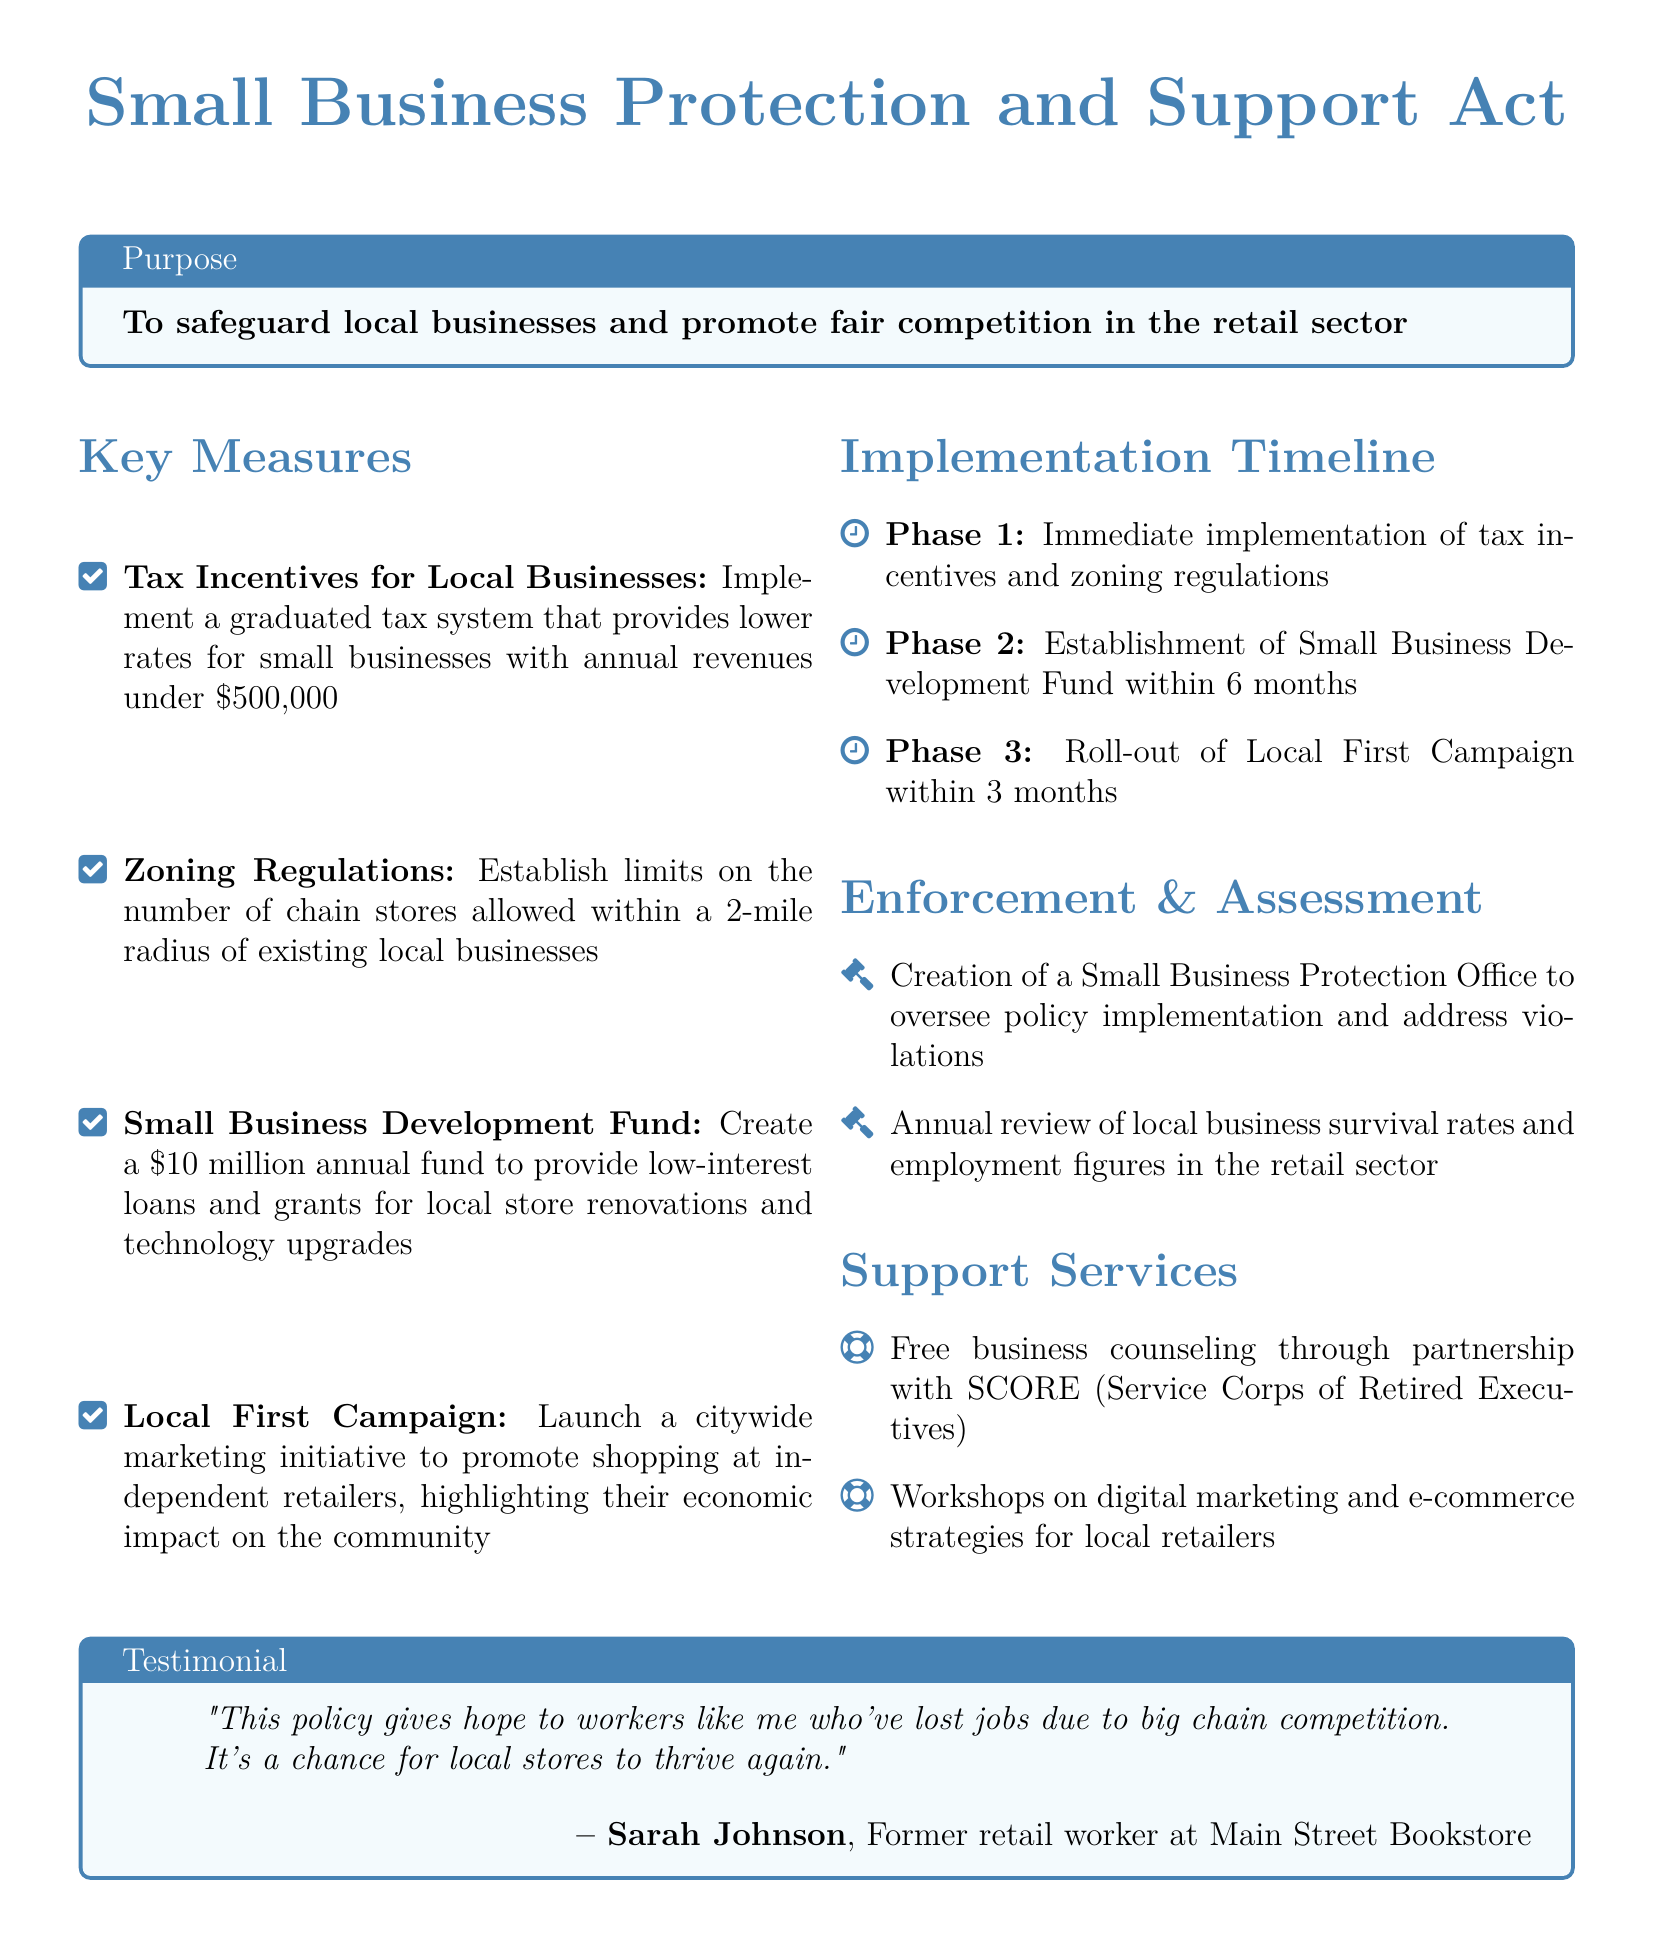What is the purpose of the policy? The purpose is stated to safeguard local businesses and promote fair competition in the retail sector.
Answer: To safeguard local businesses and promote fair competition in the retail sector What is the annual budget for the Small Business Development Fund? The document specifies a budget for the fund to provide support to local stores.
Answer: 10 million What benefits do local businesses receive through tax incentives? The details indicate that the tax system favors small businesses with specific revenue criteria.
Answer: Lower rates How long will it take to establish the Small Business Development Fund? The document outlines a timeline for the fund's establishment.
Answer: Within 6 months What initiative promotes shopping at independent retailers? There is a specific campaign mentioned aimed at encouraging community support for local stores.
Answer: Local First Campaign Who will oversee policy implementation? The document mentions a specific office created for this purpose.
Answer: Small Business Protection Office What kind of support services are offered to local retailers? The document lists various types of support services available for local businesses.
Answer: Business counseling and workshops What is the initial phase of the implementation timeline? The document outlines phases for the implementation of measures.
Answer: Immediate implementation of tax incentives and zoning regulations 